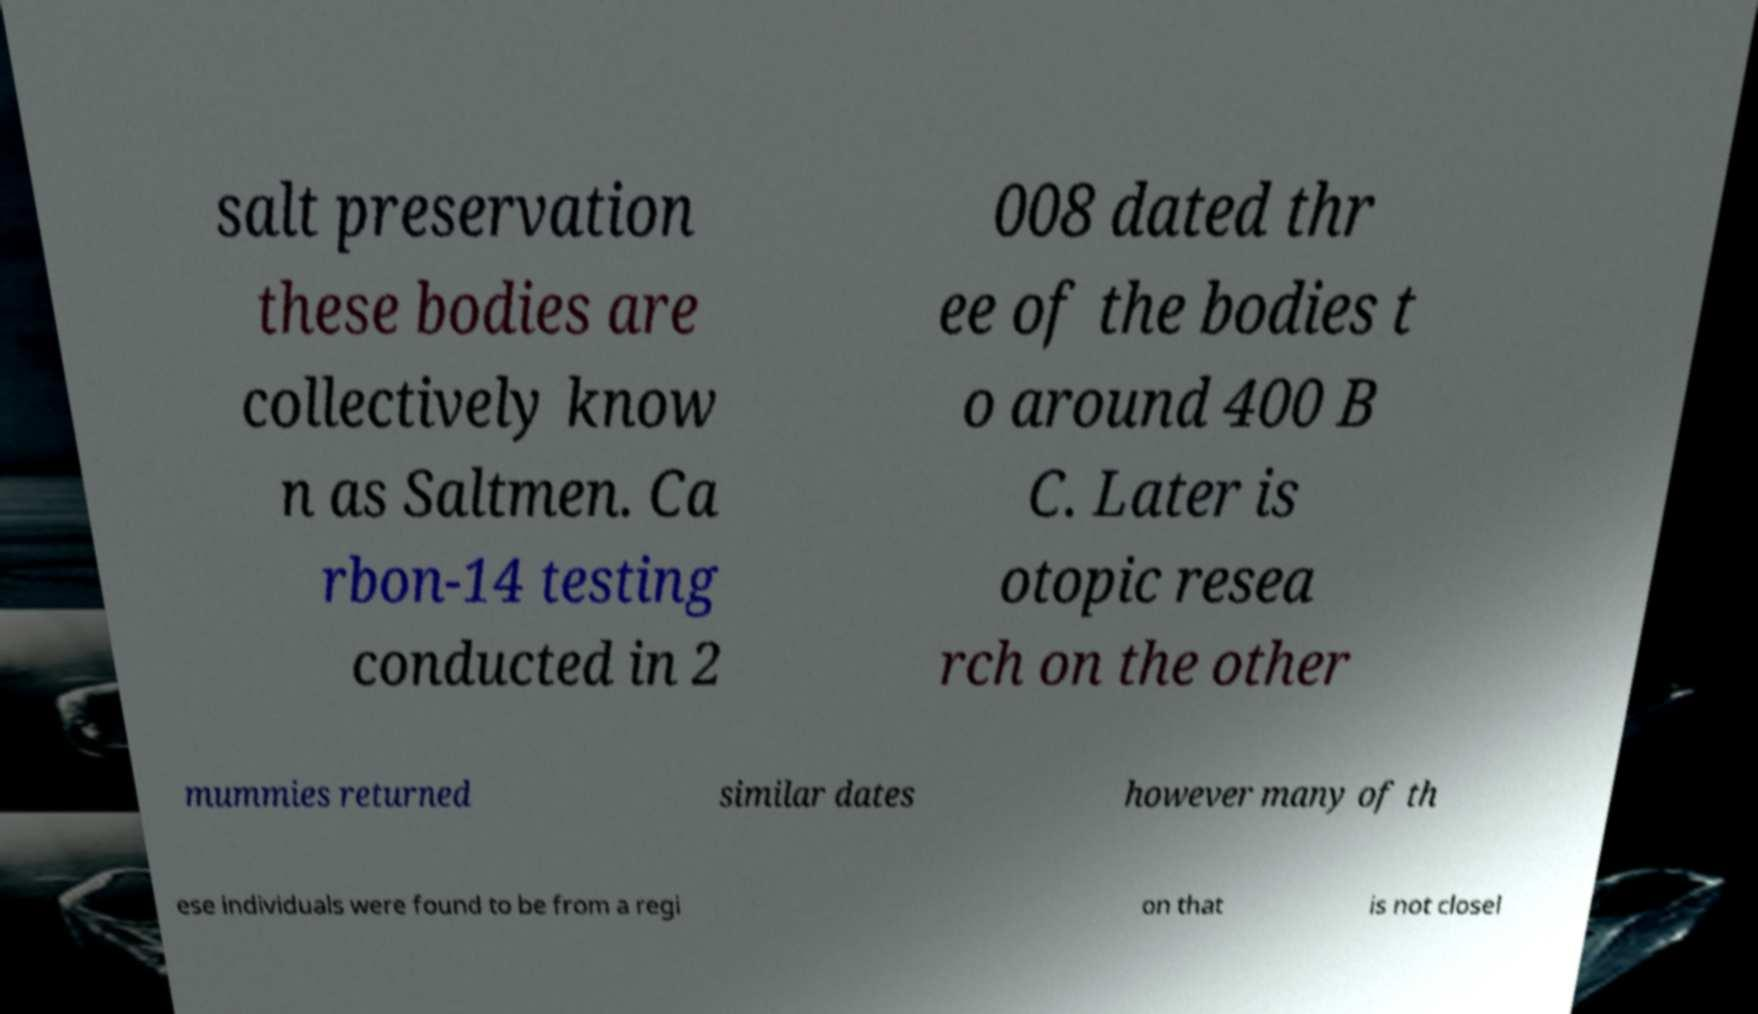Please identify and transcribe the text found in this image. salt preservation these bodies are collectively know n as Saltmen. Ca rbon-14 testing conducted in 2 008 dated thr ee of the bodies t o around 400 B C. Later is otopic resea rch on the other mummies returned similar dates however many of th ese individuals were found to be from a regi on that is not closel 